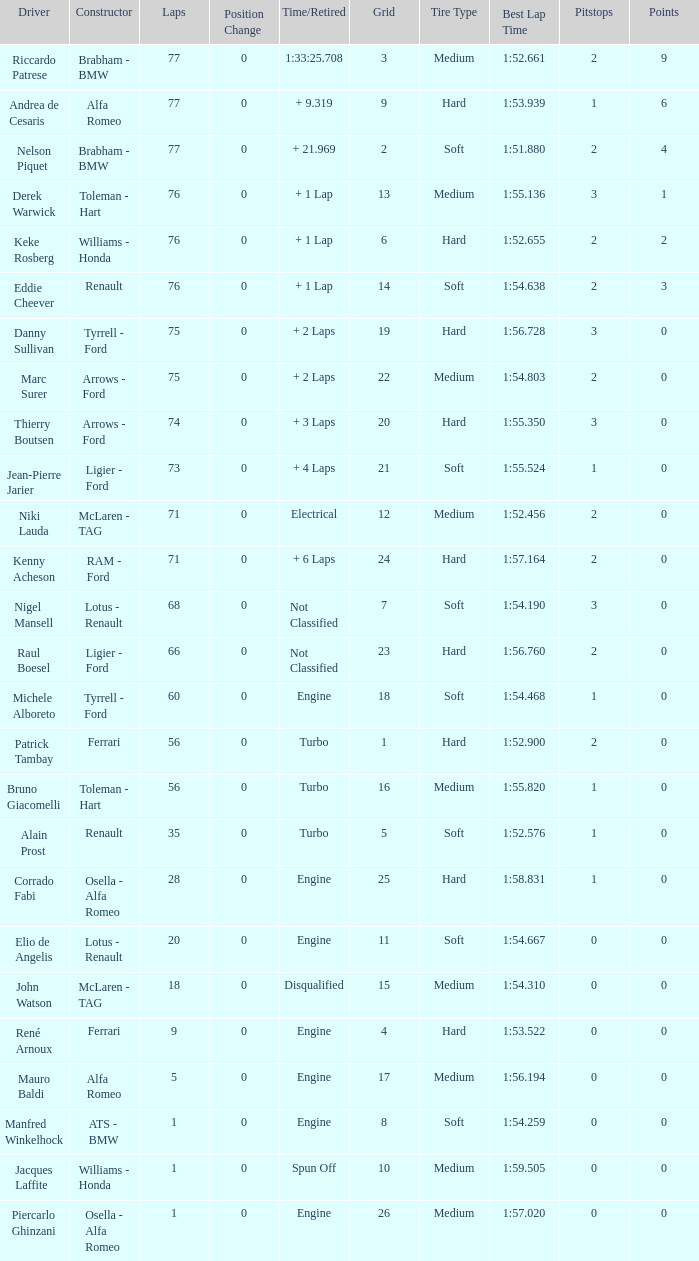Who drive the car that went under 60 laps and spun off? Jacques Laffite. Give me the full table as a dictionary. {'header': ['Driver', 'Constructor', 'Laps', 'Position Change', 'Time/Retired', 'Grid', 'Tire Type', 'Best Lap Time', 'Pitstops', 'Points'], 'rows': [['Riccardo Patrese', 'Brabham - BMW', '77', '0', '1:33:25.708', '3', 'Medium', '1:52.661', '2', '9'], ['Andrea de Cesaris', 'Alfa Romeo', '77', '0', '+ 9.319', '9', 'Hard', '1:53.939', '1', '6'], ['Nelson Piquet', 'Brabham - BMW', '77', '0', '+ 21.969', '2', 'Soft', '1:51.880', '2', '4'], ['Derek Warwick', 'Toleman - Hart', '76', '0', '+ 1 Lap', '13', 'Medium', '1:55.136', '3', '1'], ['Keke Rosberg', 'Williams - Honda', '76', '0', '+ 1 Lap', '6', 'Hard', '1:52.655', '2', '2'], ['Eddie Cheever', 'Renault', '76', '0', '+ 1 Lap', '14', 'Soft', '1:54.638', '2', '3'], ['Danny Sullivan', 'Tyrrell - Ford', '75', '0', '+ 2 Laps', '19', 'Hard', '1:56.728', '3', '0'], ['Marc Surer', 'Arrows - Ford', '75', '0', '+ 2 Laps', '22', 'Medium', '1:54.803', '2', '0'], ['Thierry Boutsen', 'Arrows - Ford', '74', '0', '+ 3 Laps', '20', 'Hard', '1:55.350', '3', '0'], ['Jean-Pierre Jarier', 'Ligier - Ford', '73', '0', '+ 4 Laps', '21', 'Soft', '1:55.524', '1', '0'], ['Niki Lauda', 'McLaren - TAG', '71', '0', 'Electrical', '12', 'Medium', '1:52.456', '2', '0'], ['Kenny Acheson', 'RAM - Ford', '71', '0', '+ 6 Laps', '24', 'Hard', '1:57.164', '2', '0'], ['Nigel Mansell', 'Lotus - Renault', '68', '0', 'Not Classified', '7', 'Soft', '1:54.190', '3', '0'], ['Raul Boesel', 'Ligier - Ford', '66', '0', 'Not Classified', '23', 'Hard', '1:56.760', '2', '0'], ['Michele Alboreto', 'Tyrrell - Ford', '60', '0', 'Engine', '18', 'Soft', '1:54.468', '1', '0'], ['Patrick Tambay', 'Ferrari', '56', '0', 'Turbo', '1', 'Hard', '1:52.900', '2', '0'], ['Bruno Giacomelli', 'Toleman - Hart', '56', '0', 'Turbo', '16', 'Medium', '1:55.820', '1', '0'], ['Alain Prost', 'Renault', '35', '0', 'Turbo', '5', 'Soft', '1:52.576', '1', '0'], ['Corrado Fabi', 'Osella - Alfa Romeo', '28', '0', 'Engine', '25', 'Hard', '1:58.831', '1', '0'], ['Elio de Angelis', 'Lotus - Renault', '20', '0', 'Engine', '11', 'Soft', '1:54.667', '0', '0'], ['John Watson', 'McLaren - TAG', '18', '0', 'Disqualified', '15', 'Medium', '1:54.310', '0', '0'], ['René Arnoux', 'Ferrari', '9', '0', 'Engine', '4', 'Hard', '1:53.522', '0', '0'], ['Mauro Baldi', 'Alfa Romeo', '5', '0', 'Engine', '17', 'Medium', '1:56.194', '0', '0'], ['Manfred Winkelhock', 'ATS - BMW', '1', '0', 'Engine', '8', 'Soft', '1:54.259', '0', '0'], ['Jacques Laffite', 'Williams - Honda', '1', '0', 'Spun Off', '10', 'Medium', '1:59.505', '0', '0'], ['Piercarlo Ghinzani', 'Osella - Alfa Romeo', '1', '0', 'Engine', '26', 'Medium', '1:57.020', '0', '0']]} 